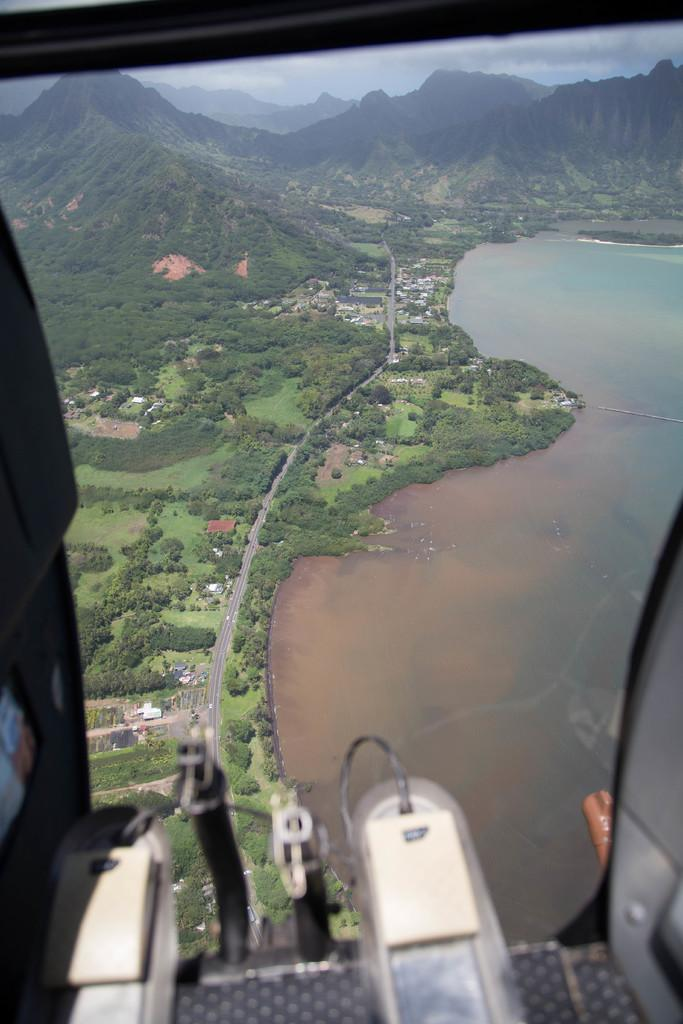What object is present in the image that can hold a liquid? There is a glass in the image. What can be seen in the background of the image through the glass? Trees, hills, and buildings are visible in the background of the image through the glass. Is there any water visible in the image? Yes, there is water visible in the image. What type of creature is holding the twig in the middle of the image? There is no creature or twig present in the image. 